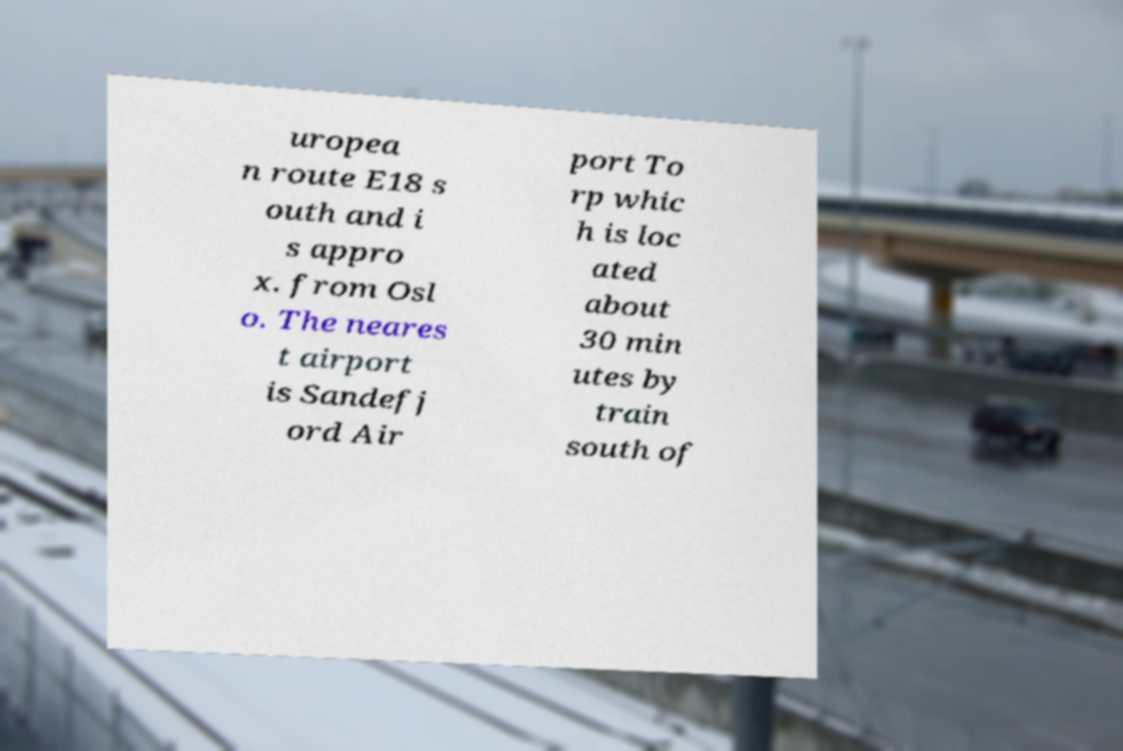Can you read and provide the text displayed in the image?This photo seems to have some interesting text. Can you extract and type it out for me? uropea n route E18 s outh and i s appro x. from Osl o. The neares t airport is Sandefj ord Air port To rp whic h is loc ated about 30 min utes by train south of 